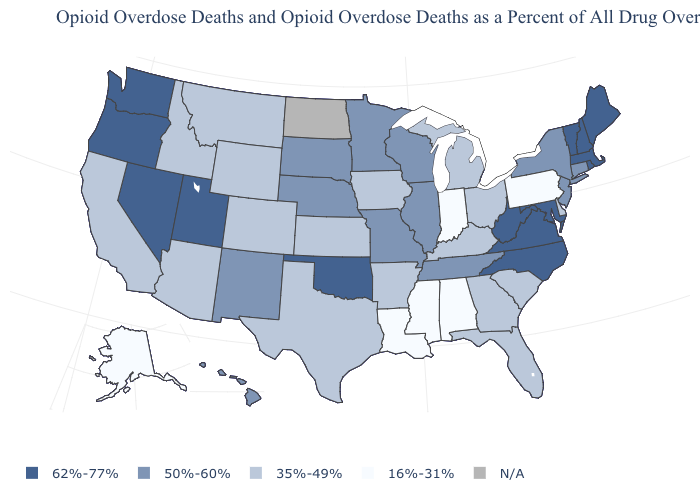Name the states that have a value in the range N/A?
Quick response, please. North Dakota. What is the value of Mississippi?
Answer briefly. 16%-31%. Among the states that border Ohio , which have the lowest value?
Quick response, please. Indiana, Pennsylvania. Is the legend a continuous bar?
Write a very short answer. No. Among the states that border Georgia , which have the highest value?
Give a very brief answer. North Carolina. What is the value of Alabama?
Answer briefly. 16%-31%. What is the lowest value in the USA?
Keep it brief. 16%-31%. What is the lowest value in the USA?
Be succinct. 16%-31%. What is the value of New Hampshire?
Quick response, please. 62%-77%. What is the value of Wyoming?
Give a very brief answer. 35%-49%. What is the highest value in states that border Nevada?
Keep it brief. 62%-77%. How many symbols are there in the legend?
Be succinct. 5. Does the map have missing data?
Short answer required. Yes. What is the value of Missouri?
Answer briefly. 50%-60%. 